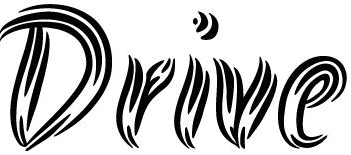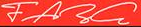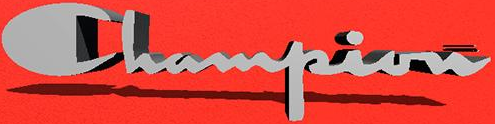What text appears in these images from left to right, separated by a semicolon? Drive; FARG; Champion 